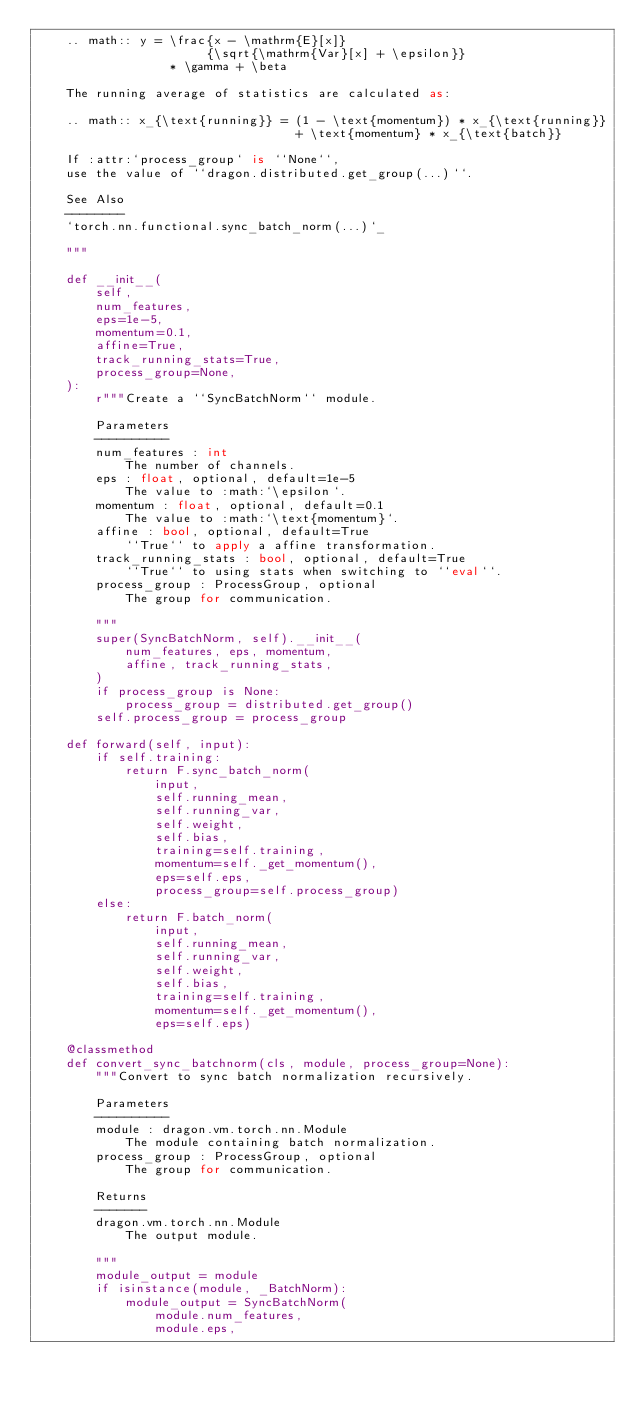<code> <loc_0><loc_0><loc_500><loc_500><_Python_>    .. math:: y = \frac{x - \mathrm{E}[x]}
                       {\sqrt{\mathrm{Var}[x] + \epsilon}}
                  * \gamma + \beta

    The running average of statistics are calculated as:

    .. math:: x_{\text{running}} = (1 - \text{momentum}) * x_{\text{running}}
                                   + \text{momentum} * x_{\text{batch}}

    If :attr:`process_group` is ``None``,
    use the value of ``dragon.distributed.get_group(...)``.

    See Also
    --------
    `torch.nn.functional.sync_batch_norm(...)`_

    """

    def __init__(
        self,
        num_features,
        eps=1e-5,
        momentum=0.1,
        affine=True,
        track_running_stats=True,
        process_group=None,
    ):
        r"""Create a ``SyncBatchNorm`` module.

        Parameters
        ----------
        num_features : int
            The number of channels.
        eps : float, optional, default=1e-5
            The value to :math:`\epsilon`.
        momentum : float, optional, default=0.1
            The value to :math:`\text{momentum}`.
        affine : bool, optional, default=True
            ``True`` to apply a affine transformation.
        track_running_stats : bool, optional, default=True
            ``True`` to using stats when switching to ``eval``.
        process_group : ProcessGroup, optional
            The group for communication.

        """
        super(SyncBatchNorm, self).__init__(
            num_features, eps, momentum,
            affine, track_running_stats,
        )
        if process_group is None:
            process_group = distributed.get_group()
        self.process_group = process_group

    def forward(self, input):
        if self.training:
            return F.sync_batch_norm(
                input,
                self.running_mean,
                self.running_var,
                self.weight,
                self.bias,
                training=self.training,
                momentum=self._get_momentum(),
                eps=self.eps,
                process_group=self.process_group)
        else:
            return F.batch_norm(
                input,
                self.running_mean,
                self.running_var,
                self.weight,
                self.bias,
                training=self.training,
                momentum=self._get_momentum(),
                eps=self.eps)

    @classmethod
    def convert_sync_batchnorm(cls, module, process_group=None):
        """Convert to sync batch normalization recursively.

        Parameters
        ----------
        module : dragon.vm.torch.nn.Module
            The module containing batch normalization.
        process_group : ProcessGroup, optional
            The group for communication.

        Returns
        -------
        dragon.vm.torch.nn.Module
            The output module.

        """
        module_output = module
        if isinstance(module, _BatchNorm):
            module_output = SyncBatchNorm(
                module.num_features,
                module.eps,</code> 